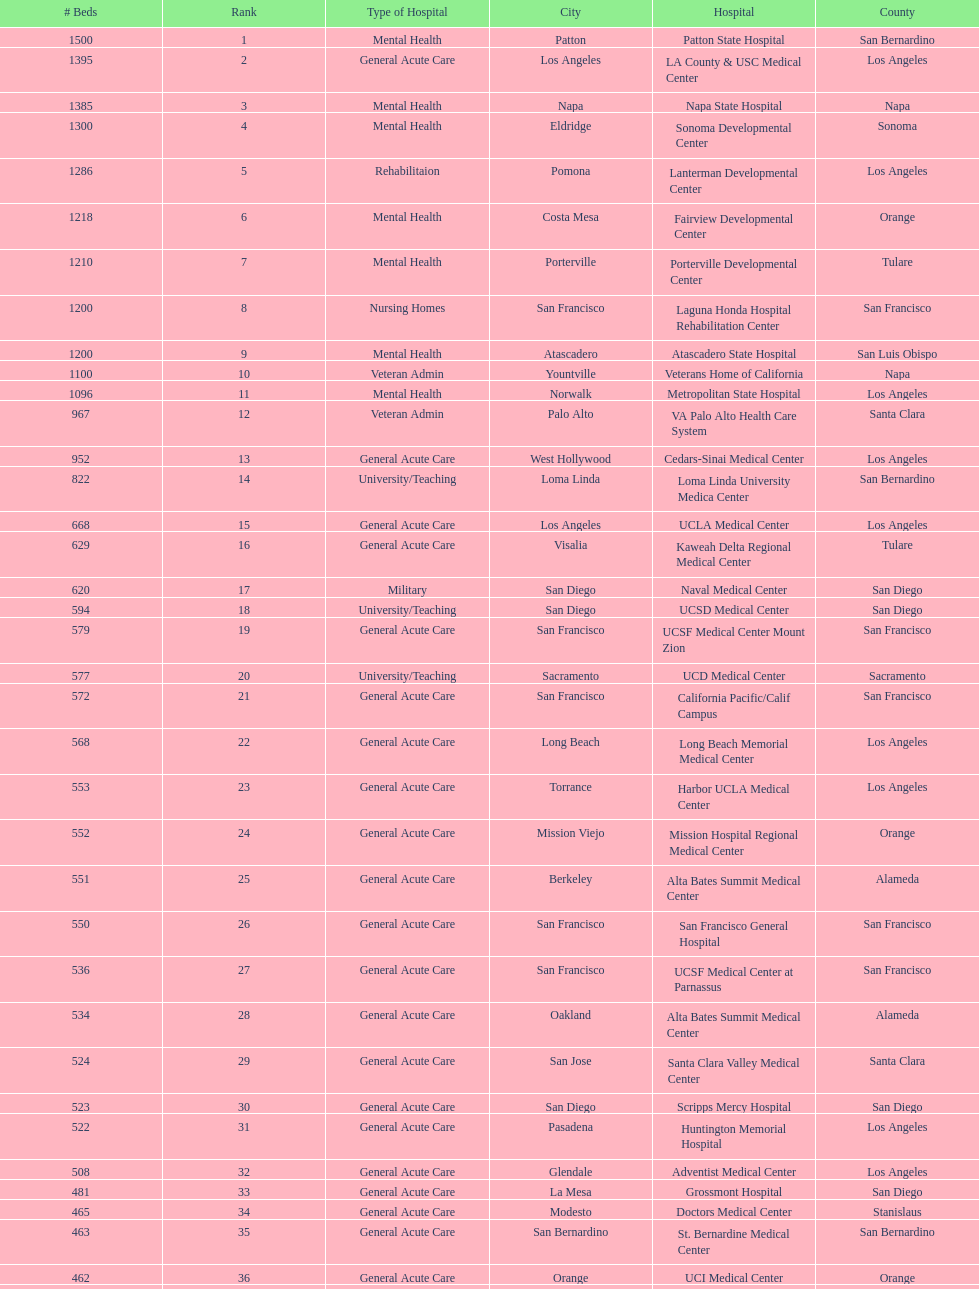What hospital in los angeles county providing hospital beds specifically for rehabilitation is ranked at least among the top 10 hospitals? Lanterman Developmental Center. Could you parse the entire table? {'header': ['# Beds', 'Rank', 'Type of Hospital', 'City', 'Hospital', 'County'], 'rows': [['1500', '1', 'Mental Health', 'Patton', 'Patton State Hospital', 'San Bernardino'], ['1395', '2', 'General Acute Care', 'Los Angeles', 'LA County & USC Medical Center', 'Los Angeles'], ['1385', '3', 'Mental Health', 'Napa', 'Napa State Hospital', 'Napa'], ['1300', '4', 'Mental Health', 'Eldridge', 'Sonoma Developmental Center', 'Sonoma'], ['1286', '5', 'Rehabilitaion', 'Pomona', 'Lanterman Developmental Center', 'Los Angeles'], ['1218', '6', 'Mental Health', 'Costa Mesa', 'Fairview Developmental Center', 'Orange'], ['1210', '7', 'Mental Health', 'Porterville', 'Porterville Developmental Center', 'Tulare'], ['1200', '8', 'Nursing Homes', 'San Francisco', 'Laguna Honda Hospital Rehabilitation Center', 'San Francisco'], ['1200', '9', 'Mental Health', 'Atascadero', 'Atascadero State Hospital', 'San Luis Obispo'], ['1100', '10', 'Veteran Admin', 'Yountville', 'Veterans Home of California', 'Napa'], ['1096', '11', 'Mental Health', 'Norwalk', 'Metropolitan State Hospital', 'Los Angeles'], ['967', '12', 'Veteran Admin', 'Palo Alto', 'VA Palo Alto Health Care System', 'Santa Clara'], ['952', '13', 'General Acute Care', 'West Hollywood', 'Cedars-Sinai Medical Center', 'Los Angeles'], ['822', '14', 'University/Teaching', 'Loma Linda', 'Loma Linda University Medica Center', 'San Bernardino'], ['668', '15', 'General Acute Care', 'Los Angeles', 'UCLA Medical Center', 'Los Angeles'], ['629', '16', 'General Acute Care', 'Visalia', 'Kaweah Delta Regional Medical Center', 'Tulare'], ['620', '17', 'Military', 'San Diego', 'Naval Medical Center', 'San Diego'], ['594', '18', 'University/Teaching', 'San Diego', 'UCSD Medical Center', 'San Diego'], ['579', '19', 'General Acute Care', 'San Francisco', 'UCSF Medical Center Mount Zion', 'San Francisco'], ['577', '20', 'University/Teaching', 'Sacramento', 'UCD Medical Center', 'Sacramento'], ['572', '21', 'General Acute Care', 'San Francisco', 'California Pacific/Calif Campus', 'San Francisco'], ['568', '22', 'General Acute Care', 'Long Beach', 'Long Beach Memorial Medical Center', 'Los Angeles'], ['553', '23', 'General Acute Care', 'Torrance', 'Harbor UCLA Medical Center', 'Los Angeles'], ['552', '24', 'General Acute Care', 'Mission Viejo', 'Mission Hospital Regional Medical Center', 'Orange'], ['551', '25', 'General Acute Care', 'Berkeley', 'Alta Bates Summit Medical Center', 'Alameda'], ['550', '26', 'General Acute Care', 'San Francisco', 'San Francisco General Hospital', 'San Francisco'], ['536', '27', 'General Acute Care', 'San Francisco', 'UCSF Medical Center at Parnassus', 'San Francisco'], ['534', '28', 'General Acute Care', 'Oakland', 'Alta Bates Summit Medical Center', 'Alameda'], ['524', '29', 'General Acute Care', 'San Jose', 'Santa Clara Valley Medical Center', 'Santa Clara'], ['523', '30', 'General Acute Care', 'San Diego', 'Scripps Mercy Hospital', 'San Diego'], ['522', '31', 'General Acute Care', 'Pasadena', 'Huntington Memorial Hospital', 'Los Angeles'], ['508', '32', 'General Acute Care', 'Glendale', 'Adventist Medical Center', 'Los Angeles'], ['481', '33', 'General Acute Care', 'La Mesa', 'Grossmont Hospital', 'San Diego'], ['465', '34', 'General Acute Care', 'Modesto', 'Doctors Medical Center', 'Stanislaus'], ['463', '35', 'General Acute Care', 'San Bernardino', 'St. Bernardine Medical Center', 'San Bernardino'], ['462', '36', 'General Acute Care', 'Orange', 'UCI Medical Center', 'Orange'], ['460', '37', 'General Acute Care', 'Stanford', 'Stanford Medical Center', 'Santa Clara'], ['457', '38', 'General Acute Care', 'Fresno', 'Community Regional Medical Center', 'Fresno'], ['455', '39', 'General Acute Care', 'Arcadia', 'Methodist Hospital', 'Los Angeles'], ['455', '40', 'General Acute Care', 'Burbank', 'Providence St. Joseph Medical Center', 'Los Angeles'], ['450', '41', 'General Acute Care', 'Newport Beach', 'Hoag Memorial Hospital', 'Orange'], ['450', '42', 'Mental Health', 'San Jose', 'Agnews Developmental Center', 'Santa Clara'], ['450', '43', 'Nursing Homes', 'San Francisco', 'Jewish Home', 'San Francisco'], ['448', '44', 'General Acute Care', 'Orange', 'St. Joseph Hospital Orange', 'Orange'], ['441', '45', 'General Acute Care', 'Whittier', 'Presbyterian Intercommunity', 'Los Angeles'], ['440', '46', 'General Acute Care', 'Fontana', 'Kaiser Permanente Medical Center', 'San Bernardino'], ['439', '47', 'General Acute Care', 'Los Angeles', 'Kaiser Permanente Medical Center', 'Los Angeles'], ['436', '48', 'General Acute Care', 'Pomona', 'Pomona Valley Hospital Medical Center', 'Los Angeles'], ['432', '49', 'General Acute Care', 'Sacramento', 'Sutter General Medical Center', 'Sacramento'], ['430', '50', 'General Acute Care', 'San Francisco', 'St. Mary Medical Center', 'San Francisco'], ['429', '50', 'General Acute Care', 'San Jose', 'Good Samaritan Hospital', 'Santa Clara']]} 